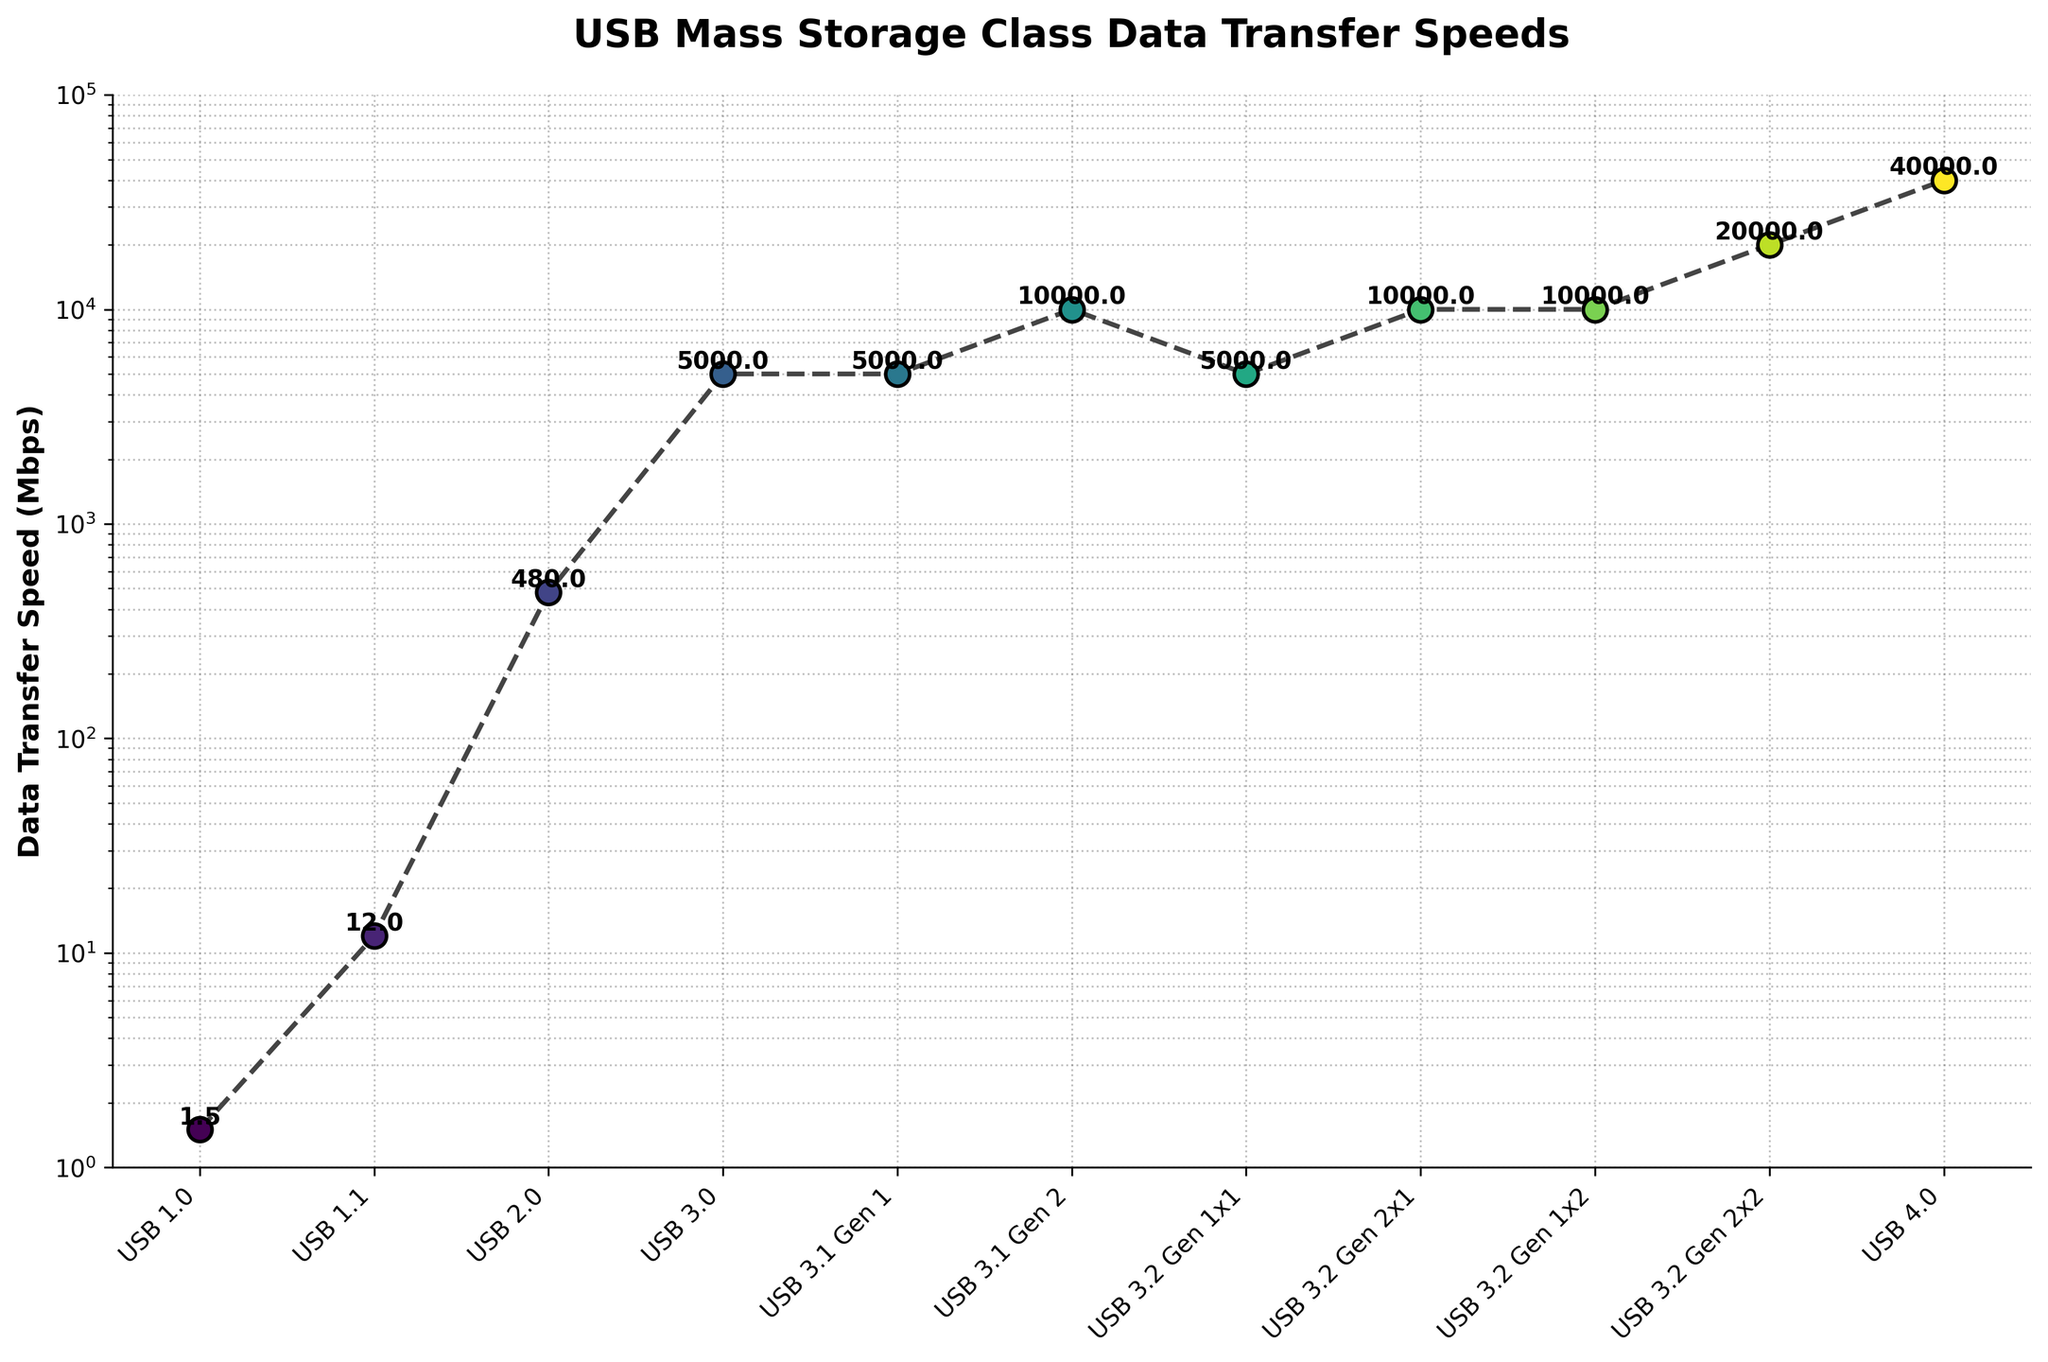What's the trend in data transfer speed from USB 1.0 to USB 4.0? The data transfer speed shows a significant increase from USB 1.0 to USB 4.0. Starting with USB 1.0 at 1.5 Mbps, it increases markedly to 12 Mbps with USB 1.1, then to 480 Mbps with USB 2.0, and continues to climb up through subsequent versions, reaching 40,000 Mbps (40 Gbps) with USB 4.0.
Answer: Significant increase Which USB version introduced the first major jump in data transfer speed? The first major jump occurs from USB 1.1 to USB 2.0, going from 12 Mbps to 480 Mbps. This is evidenced by the noticeable vertical jump between these points in the line chart.
Answer: USB 2.0 How many USB versions have a data transfer speed of 10,000 Mbps? Counting the labels on the horizontal axis that correspond to a value of 10,000 Mbps, we can see that there are three: USB 3.1 Gen 2, USB 3.2 Gen 2x1, and USB 3.2 Gen 1x2.
Answer: Three Which USB version had the biggest increase in data transfer speed compared to its predecessor? USB 3.2 Gen 2x2 shows the biggest increase compared to its predecessor USB 3.2 Gen 1x2, jumping from 10,000 Mbps to 20,000 Mbps, a difference of 10,000 Mbps, as shown by the steepest upward segment in the plot.
Answer: USB 3.2 Gen 2x2 What is the data transfer speed of USB 3.0 and how does it compare to USB 1.0? USB 3.0 has a data transfer speed of 5,000 Mbps, which is significantly higher than USB 1.0's 1.5 Mbps. The comparison shows that USB 3.0 is approximately 3,333 times faster than USB 1.0.
Answer: 5,000 Mbps; 3,333 times faster Which USB version has the lowest data transfer speed and what is it? USB 1.0 has the lowest data transfer speed at 1.5 Mbps, as shown by the lowest point on the vertical axis in the line chart.
Answer: USB 1.0; 1.5 Mbps How does the data transfer speed of USB 4.0 compare to USB 3.2 Gen 2x2? USB 4.0 has a data transfer speed of 40,000 Mbps, which is double that of USB 3.2 Gen 2x2's 20,000 Mbps.
Answer: Double What's the overall increase in data transfer speed from USB 1.0 to USB 4.0 in terms of Mbps? The overall increase is calculated by subtracting the data transfer speed of USB 1.0 from that of USB 4.0: 40,000 Mbps - 1.5 Mbps = 39,998.5 Mbps.
Answer: 39,998.5 Mbps What pattern do you observe in the data transfer speed for versions within USB 3.1 and USB 3.2? Within USB 3.1, the data transfer speed remains at 5,000 Mbps for Gen 1 and doubles to 10,000 Mbps for Gen 2. For USB 3.2, there are multiple versions with speeds of either 5,000 Mbps, 10,000 Mbps, or 20,000 Mbps, showing a mix of similar and increased speeds.
Answer: Incremental increases and mixing patterns 